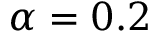Convert formula to latex. <formula><loc_0><loc_0><loc_500><loc_500>\alpha = 0 . 2</formula> 